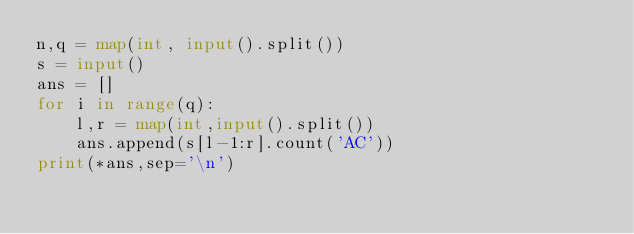Convert code to text. <code><loc_0><loc_0><loc_500><loc_500><_Python_>n,q = map(int, input().split())
s = input()
ans = []
for i in range(q):
    l,r = map(int,input().split())
    ans.append(s[l-1:r].count('AC'))
print(*ans,sep='\n')</code> 